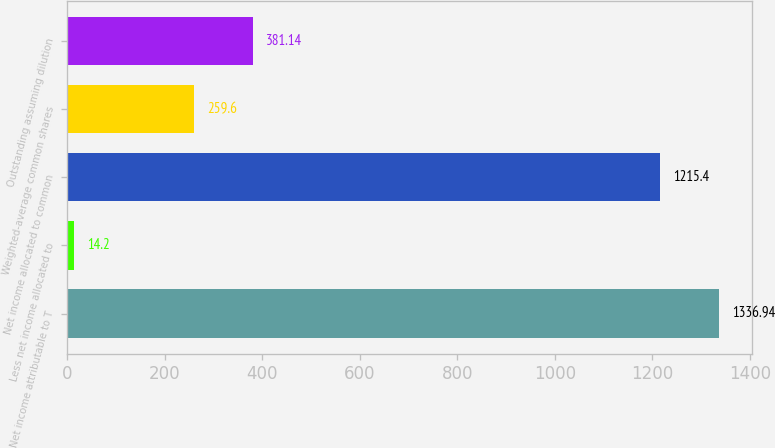Convert chart to OTSL. <chart><loc_0><loc_0><loc_500><loc_500><bar_chart><fcel>Net income attributable to T<fcel>Less net income allocated to<fcel>Net income allocated to common<fcel>Weighted-average common shares<fcel>Outstanding assuming dilution<nl><fcel>1336.94<fcel>14.2<fcel>1215.4<fcel>259.6<fcel>381.14<nl></chart> 